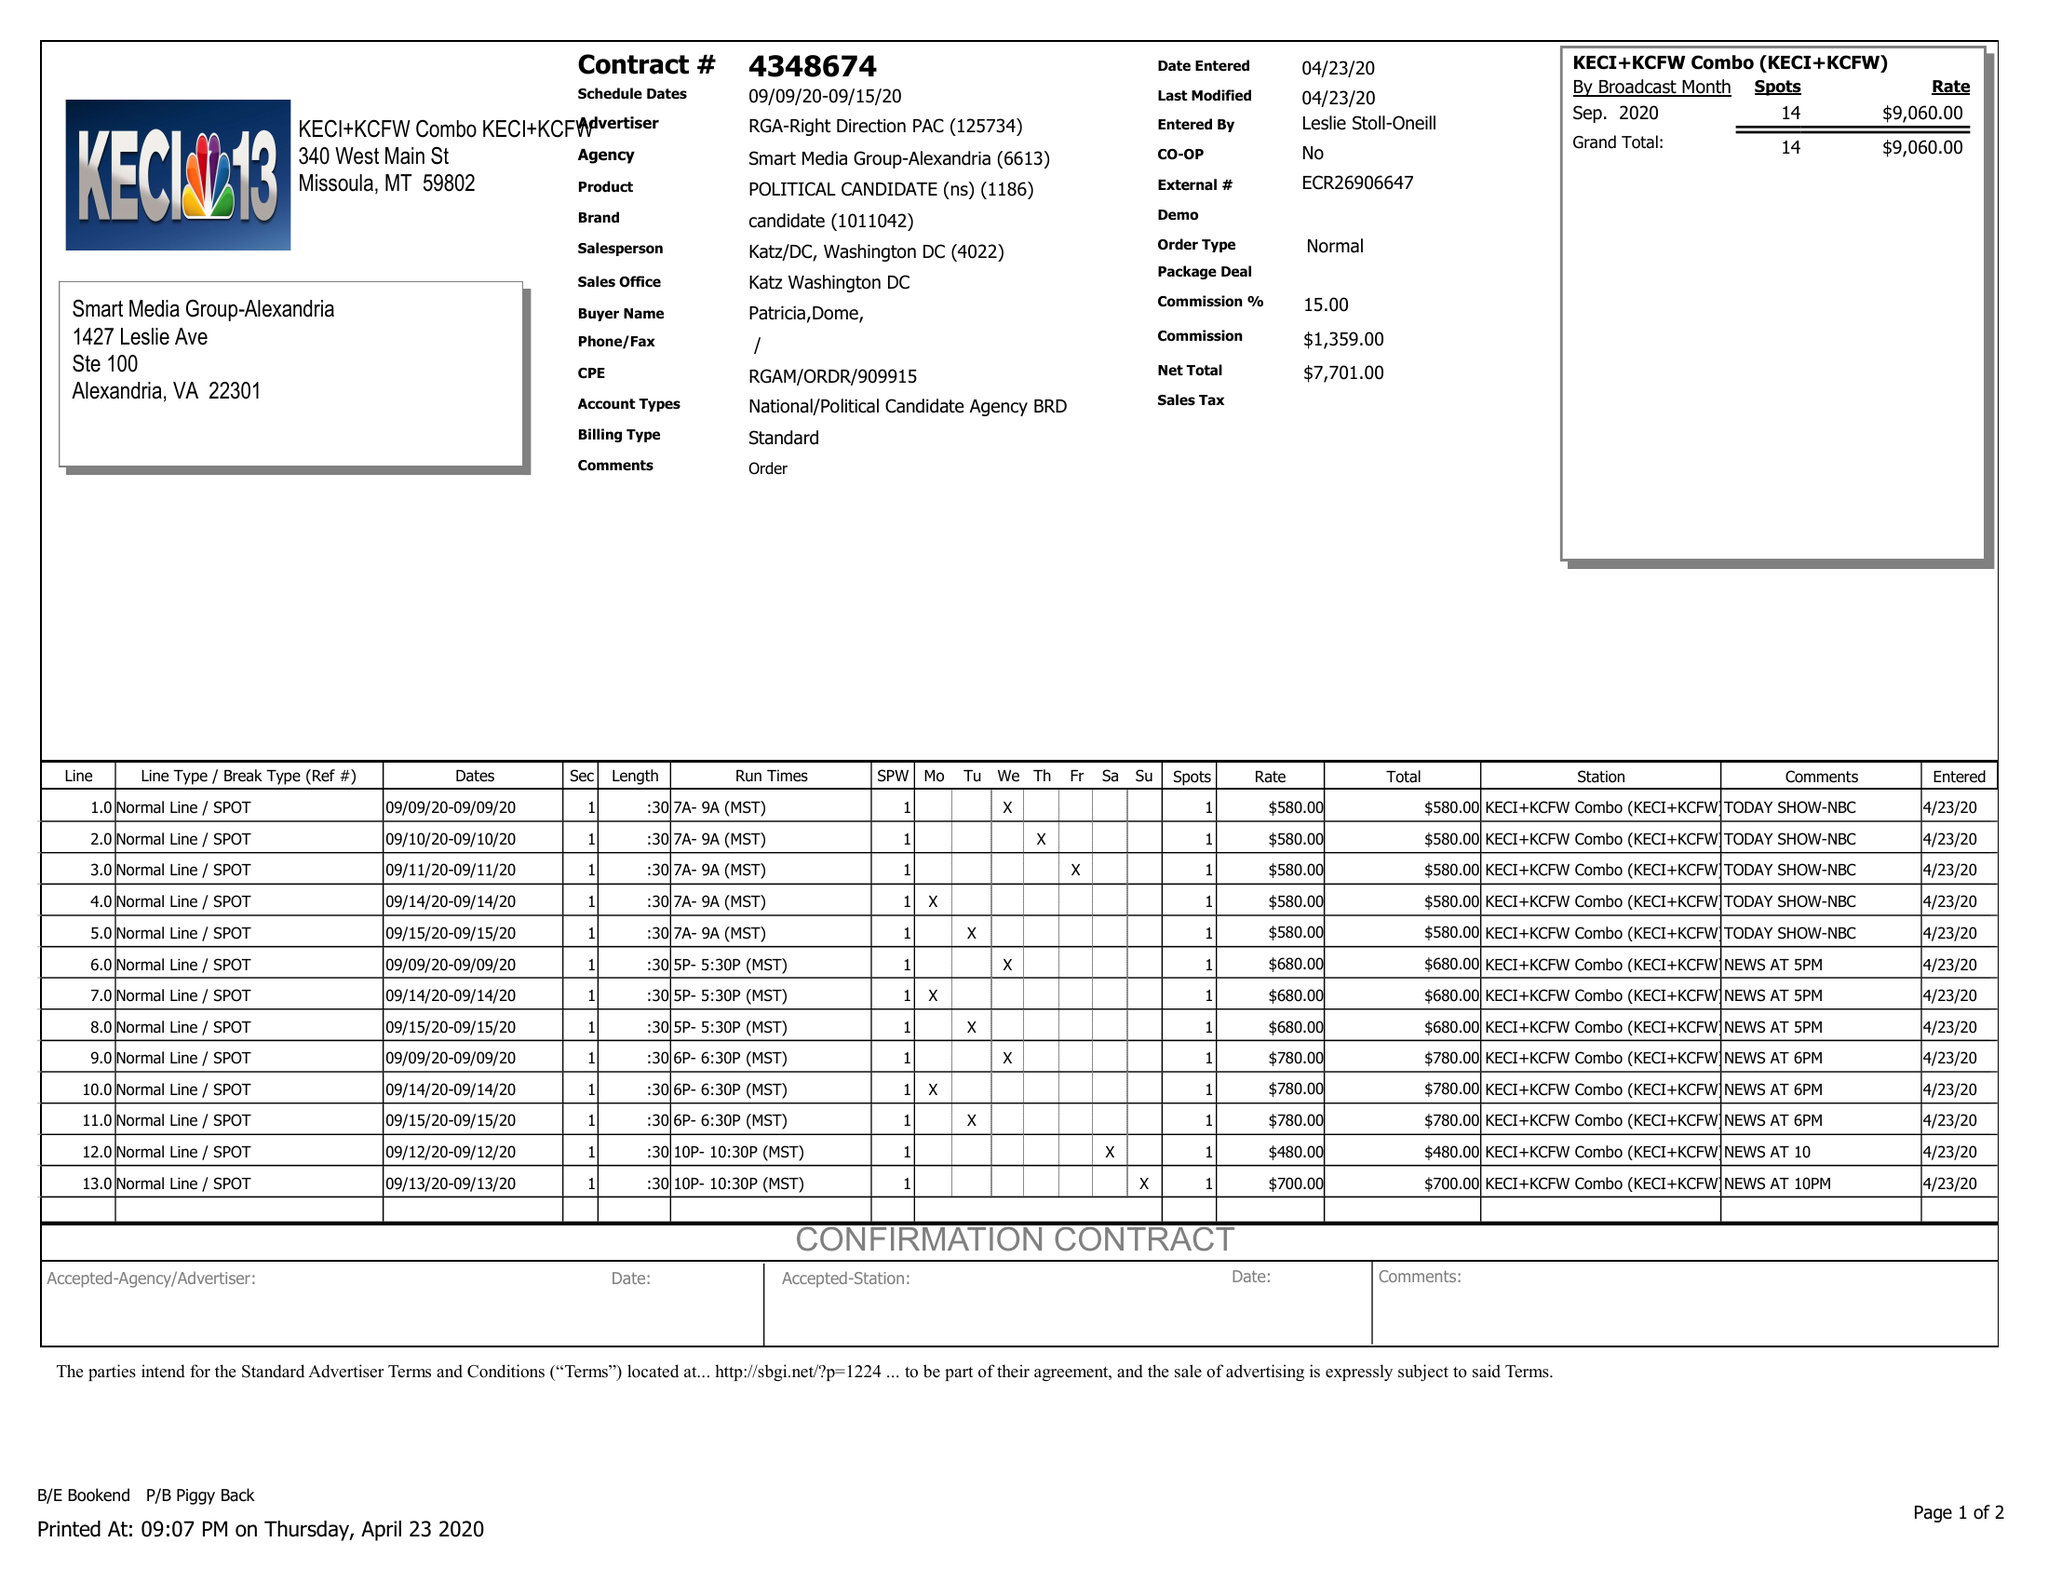What is the value for the contract_num?
Answer the question using a single word or phrase. 4348674 